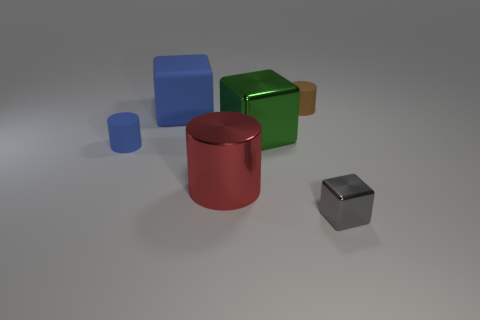Add 1 small purple things. How many objects exist? 7 Subtract all small objects. Subtract all tiny gray metallic cubes. How many objects are left? 2 Add 5 tiny blue cylinders. How many tiny blue cylinders are left? 6 Add 4 small gray metal objects. How many small gray metal objects exist? 5 Subtract 1 gray blocks. How many objects are left? 5 